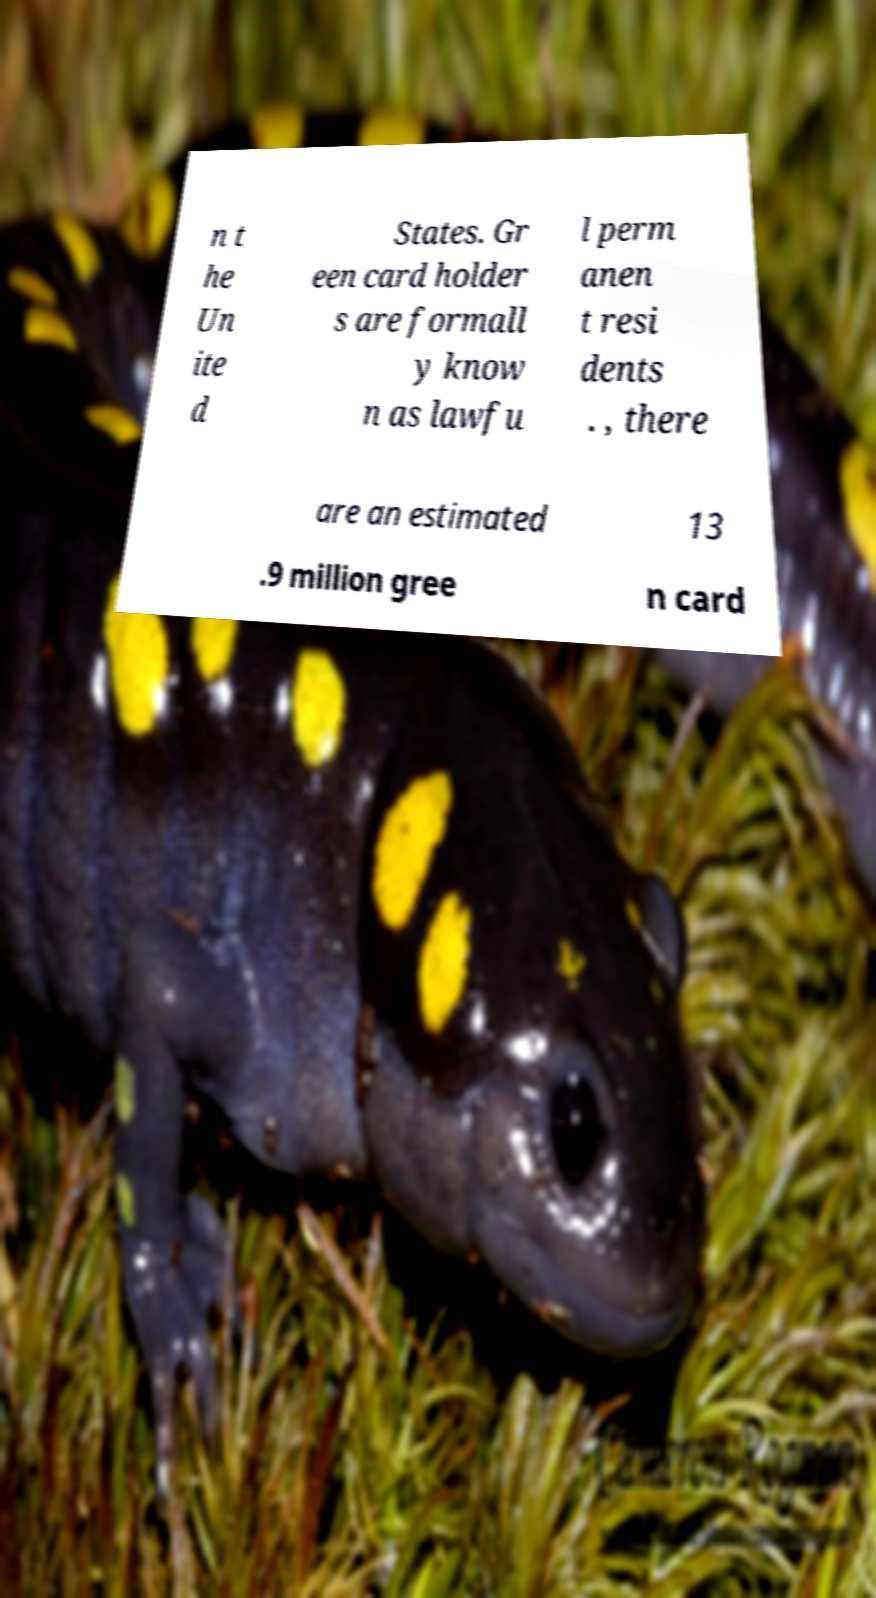Please identify and transcribe the text found in this image. n t he Un ite d States. Gr een card holder s are formall y know n as lawfu l perm anen t resi dents . , there are an estimated 13 .9 million gree n card 